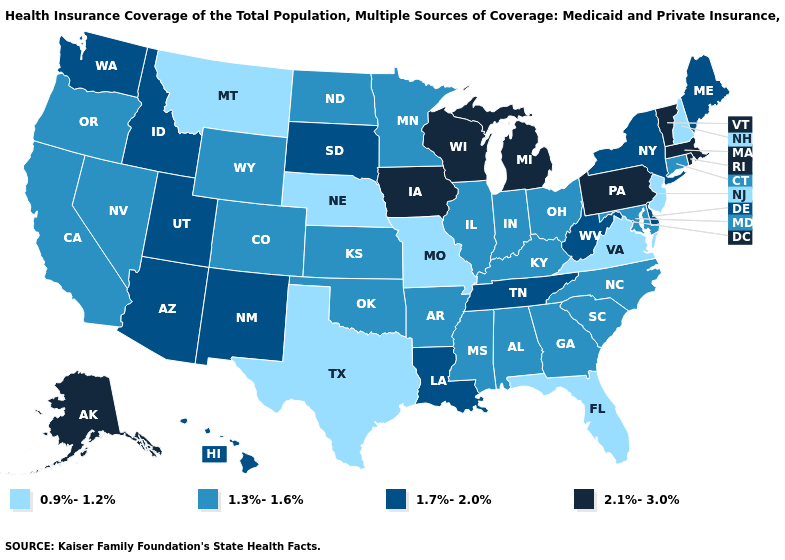Among the states that border Indiana , which have the highest value?
Be succinct. Michigan. Name the states that have a value in the range 1.3%-1.6%?
Give a very brief answer. Alabama, Arkansas, California, Colorado, Connecticut, Georgia, Illinois, Indiana, Kansas, Kentucky, Maryland, Minnesota, Mississippi, Nevada, North Carolina, North Dakota, Ohio, Oklahoma, Oregon, South Carolina, Wyoming. How many symbols are there in the legend?
Answer briefly. 4. Name the states that have a value in the range 1.7%-2.0%?
Give a very brief answer. Arizona, Delaware, Hawaii, Idaho, Louisiana, Maine, New Mexico, New York, South Dakota, Tennessee, Utah, Washington, West Virginia. Does the map have missing data?
Concise answer only. No. What is the lowest value in states that border North Dakota?
Concise answer only. 0.9%-1.2%. Name the states that have a value in the range 1.3%-1.6%?
Quick response, please. Alabama, Arkansas, California, Colorado, Connecticut, Georgia, Illinois, Indiana, Kansas, Kentucky, Maryland, Minnesota, Mississippi, Nevada, North Carolina, North Dakota, Ohio, Oklahoma, Oregon, South Carolina, Wyoming. What is the value of Wyoming?
Concise answer only. 1.3%-1.6%. Which states have the highest value in the USA?
Keep it brief. Alaska, Iowa, Massachusetts, Michigan, Pennsylvania, Rhode Island, Vermont, Wisconsin. Which states hav the highest value in the Northeast?
Give a very brief answer. Massachusetts, Pennsylvania, Rhode Island, Vermont. Does Hawaii have the lowest value in the West?
Keep it brief. No. Does New Hampshire have the same value as South Carolina?
Concise answer only. No. Is the legend a continuous bar?
Quick response, please. No. 